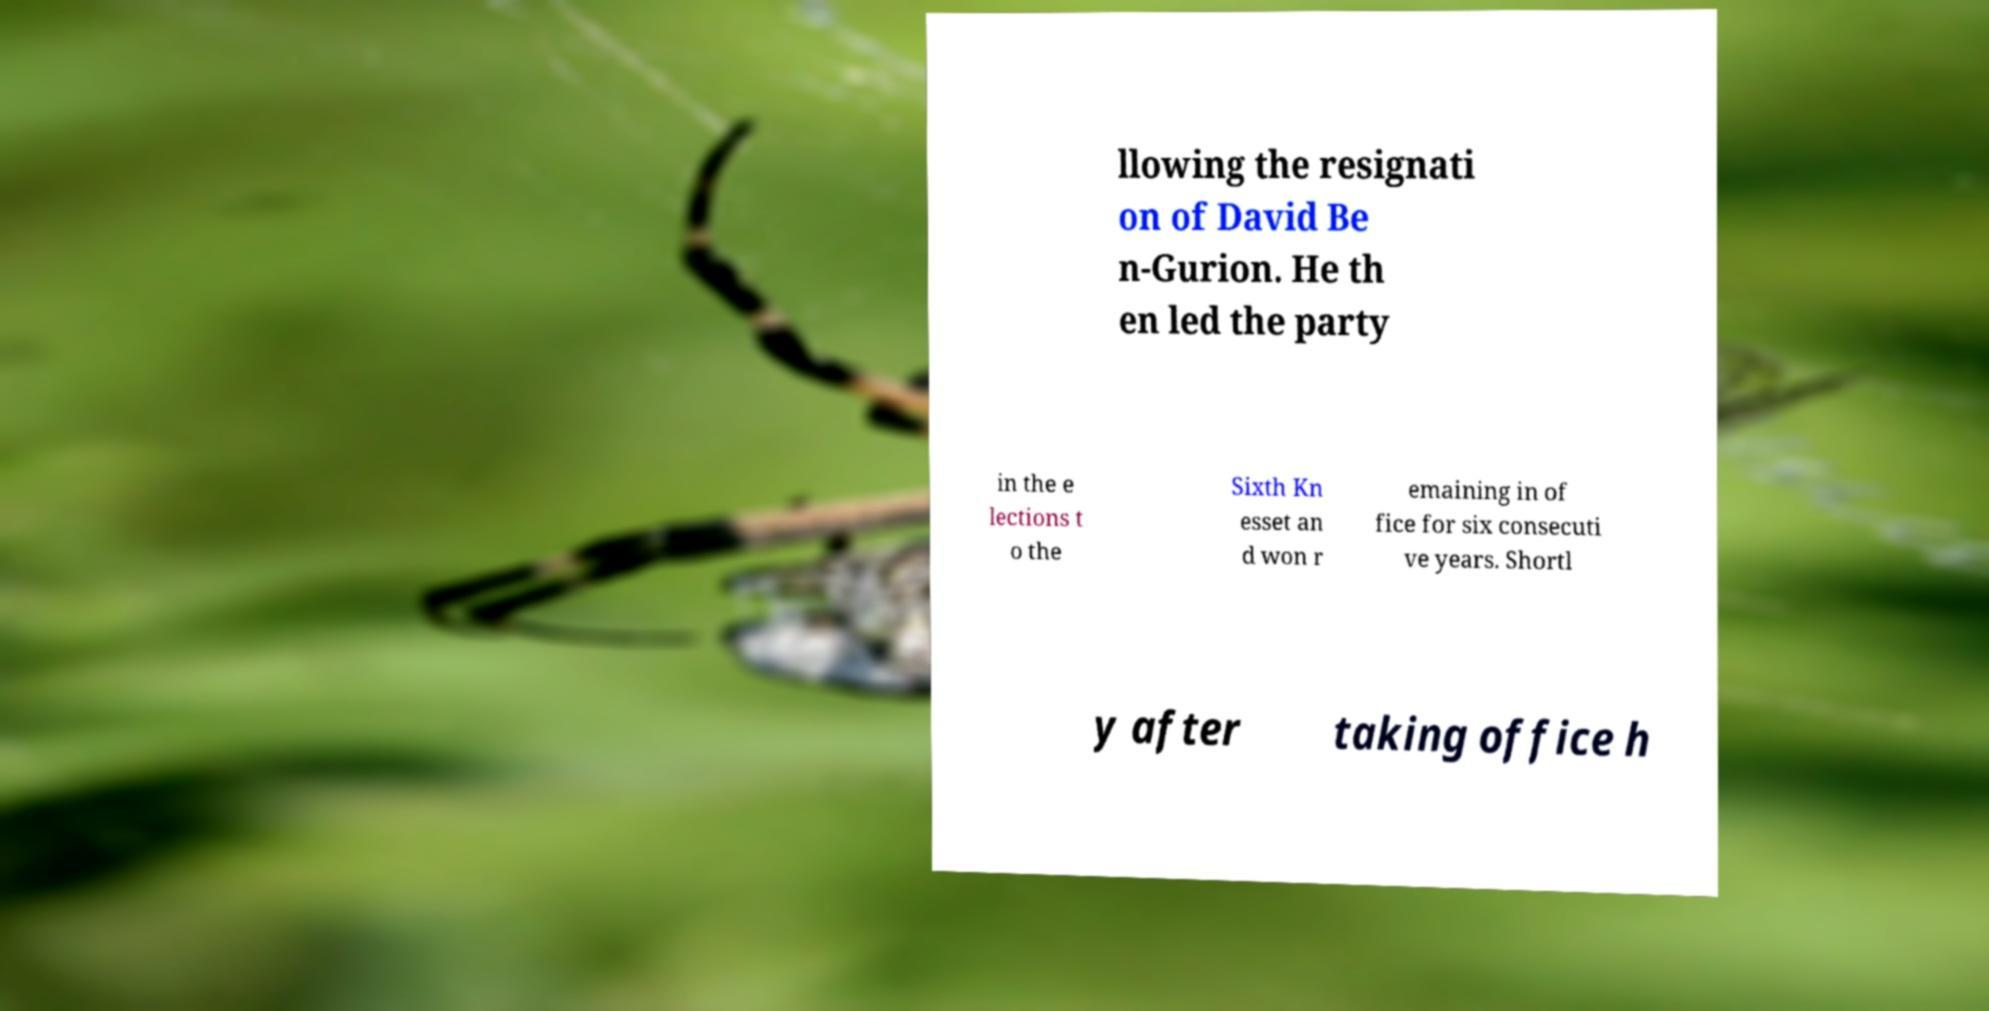Please read and relay the text visible in this image. What does it say? llowing the resignati on of David Be n-Gurion. He th en led the party in the e lections t o the Sixth Kn esset an d won r emaining in of fice for six consecuti ve years. Shortl y after taking office h 